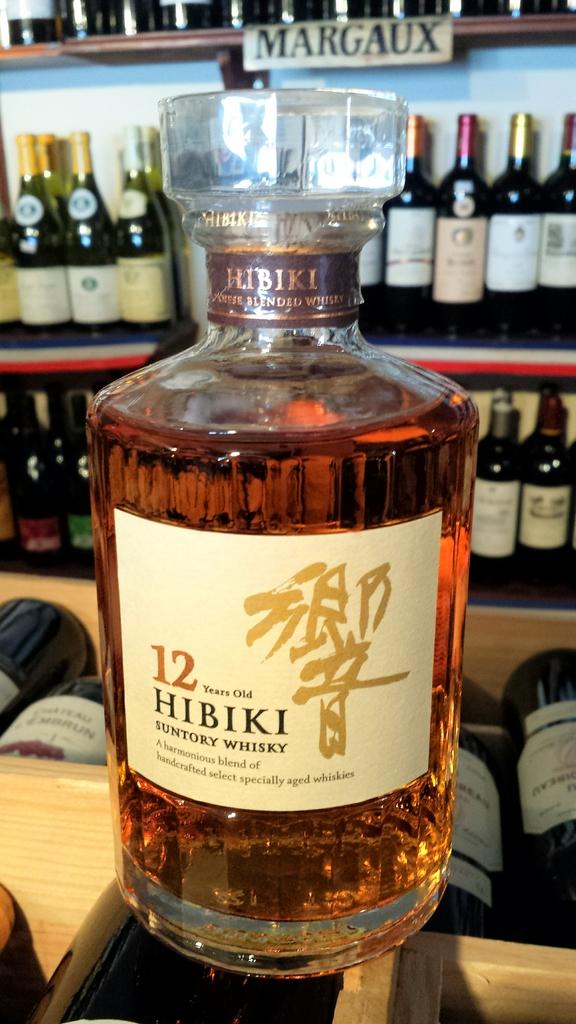What kind of whisky is this?
Offer a very short reply. Hibiki. Is this liquor?
Provide a succinct answer. Yes. 